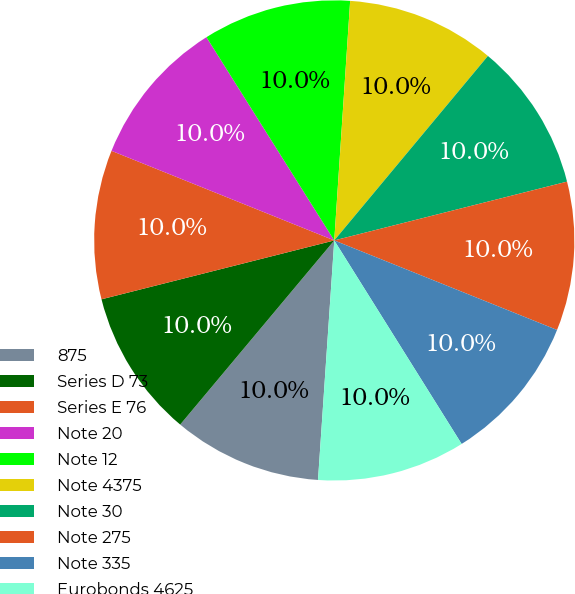<chart> <loc_0><loc_0><loc_500><loc_500><pie_chart><fcel>875<fcel>Series D 73<fcel>Series E 76<fcel>Note 20<fcel>Note 12<fcel>Note 4375<fcel>Note 30<fcel>Note 275<fcel>Note 335<fcel>Eurobonds 4625<nl><fcel>10.01%<fcel>9.97%<fcel>10.03%<fcel>9.98%<fcel>9.99%<fcel>10.0%<fcel>10.01%<fcel>10.02%<fcel>10.02%<fcel>9.98%<nl></chart> 